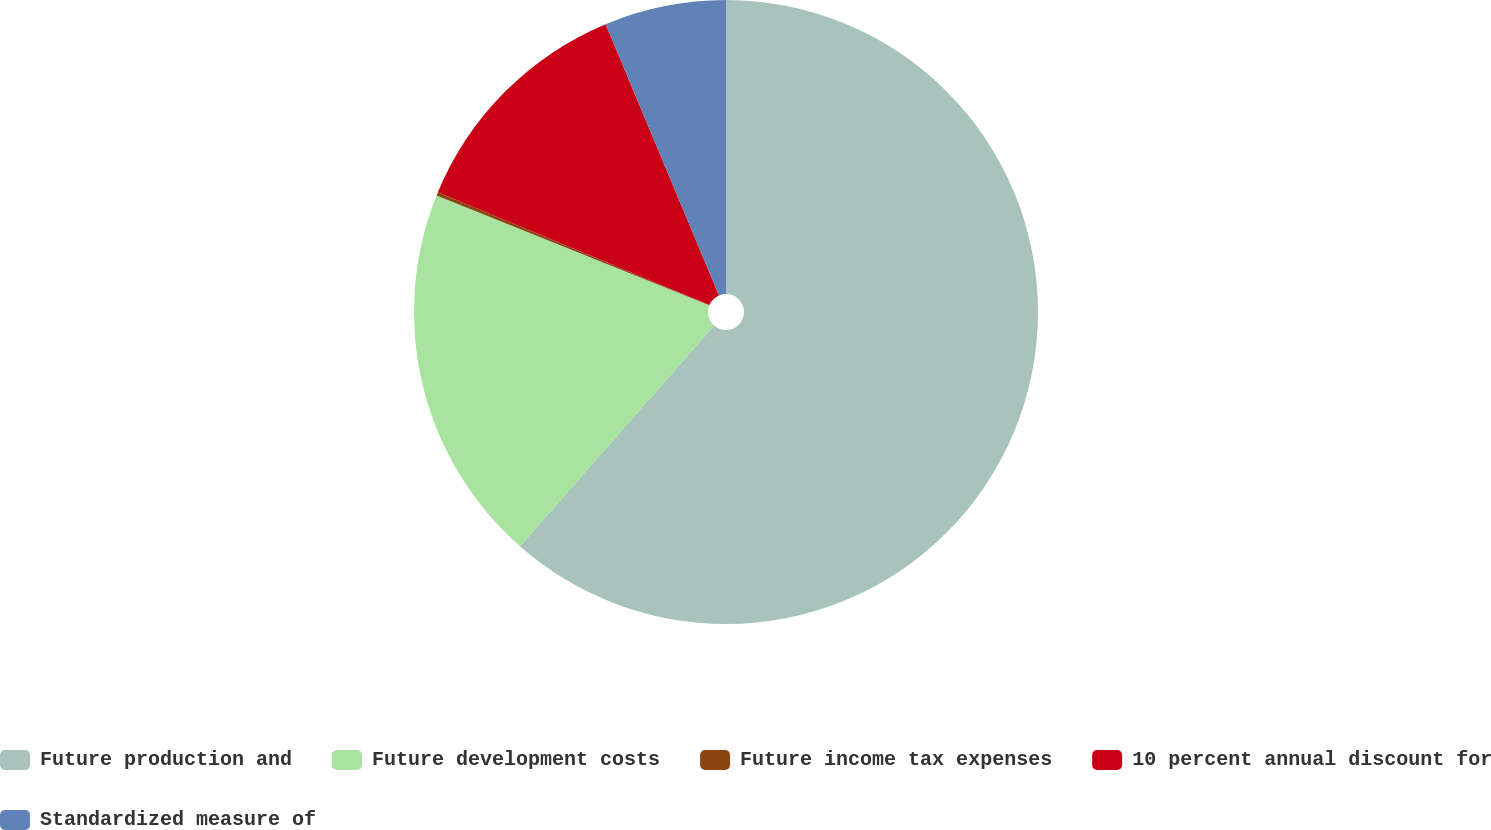Convert chart. <chart><loc_0><loc_0><loc_500><loc_500><pie_chart><fcel>Future production and<fcel>Future development costs<fcel>Future income tax expenses<fcel>10 percent annual discount for<fcel>Standardized measure of<nl><fcel>61.47%<fcel>19.61%<fcel>0.18%<fcel>12.43%<fcel>6.3%<nl></chart> 